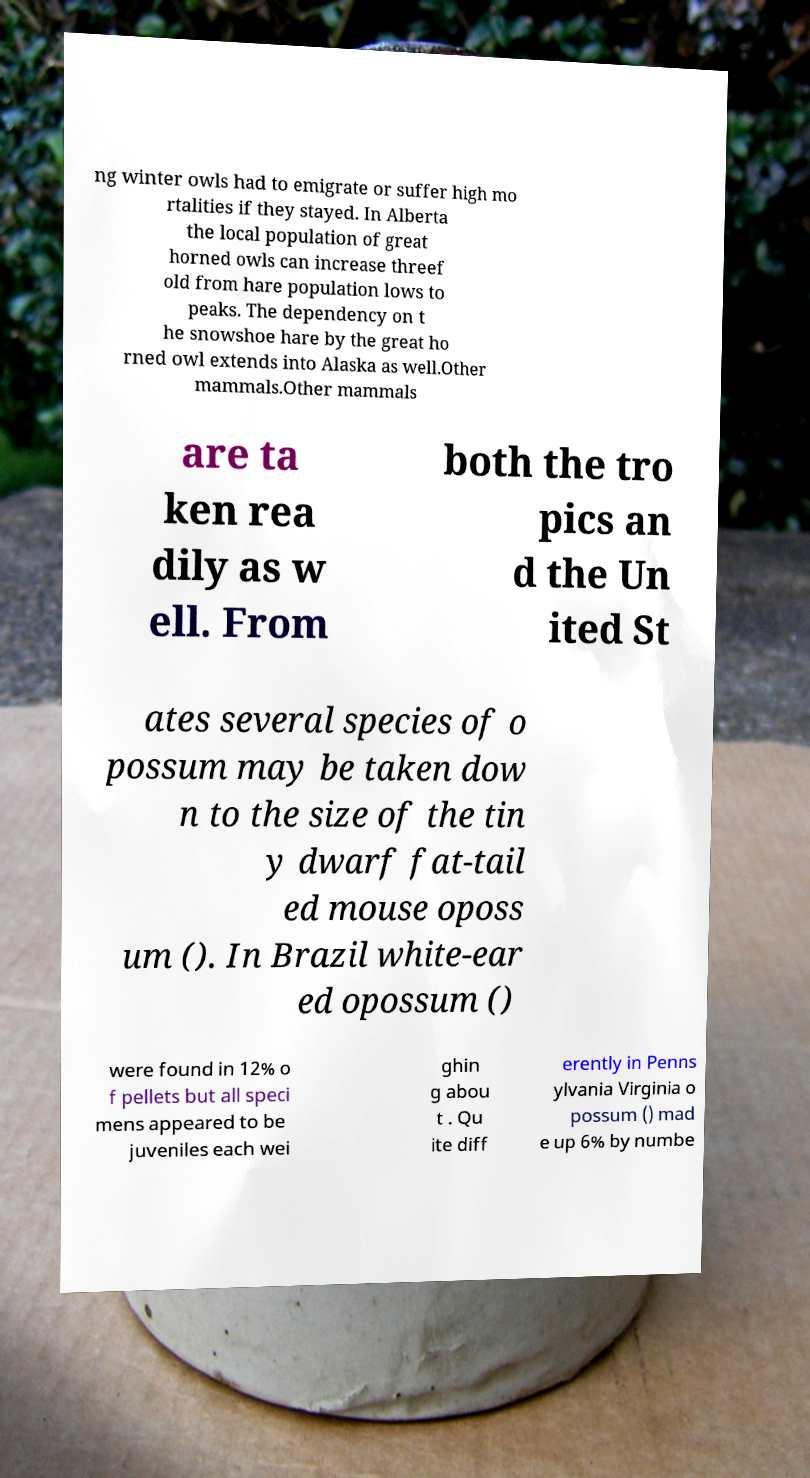Can you read and provide the text displayed in the image?This photo seems to have some interesting text. Can you extract and type it out for me? ng winter owls had to emigrate or suffer high mo rtalities if they stayed. In Alberta the local population of great horned owls can increase threef old from hare population lows to peaks. The dependency on t he snowshoe hare by the great ho rned owl extends into Alaska as well.Other mammals.Other mammals are ta ken rea dily as w ell. From both the tro pics an d the Un ited St ates several species of o possum may be taken dow n to the size of the tin y dwarf fat-tail ed mouse oposs um (). In Brazil white-ear ed opossum () were found in 12% o f pellets but all speci mens appeared to be juveniles each wei ghin g abou t . Qu ite diff erently in Penns ylvania Virginia o possum () mad e up 6% by numbe 